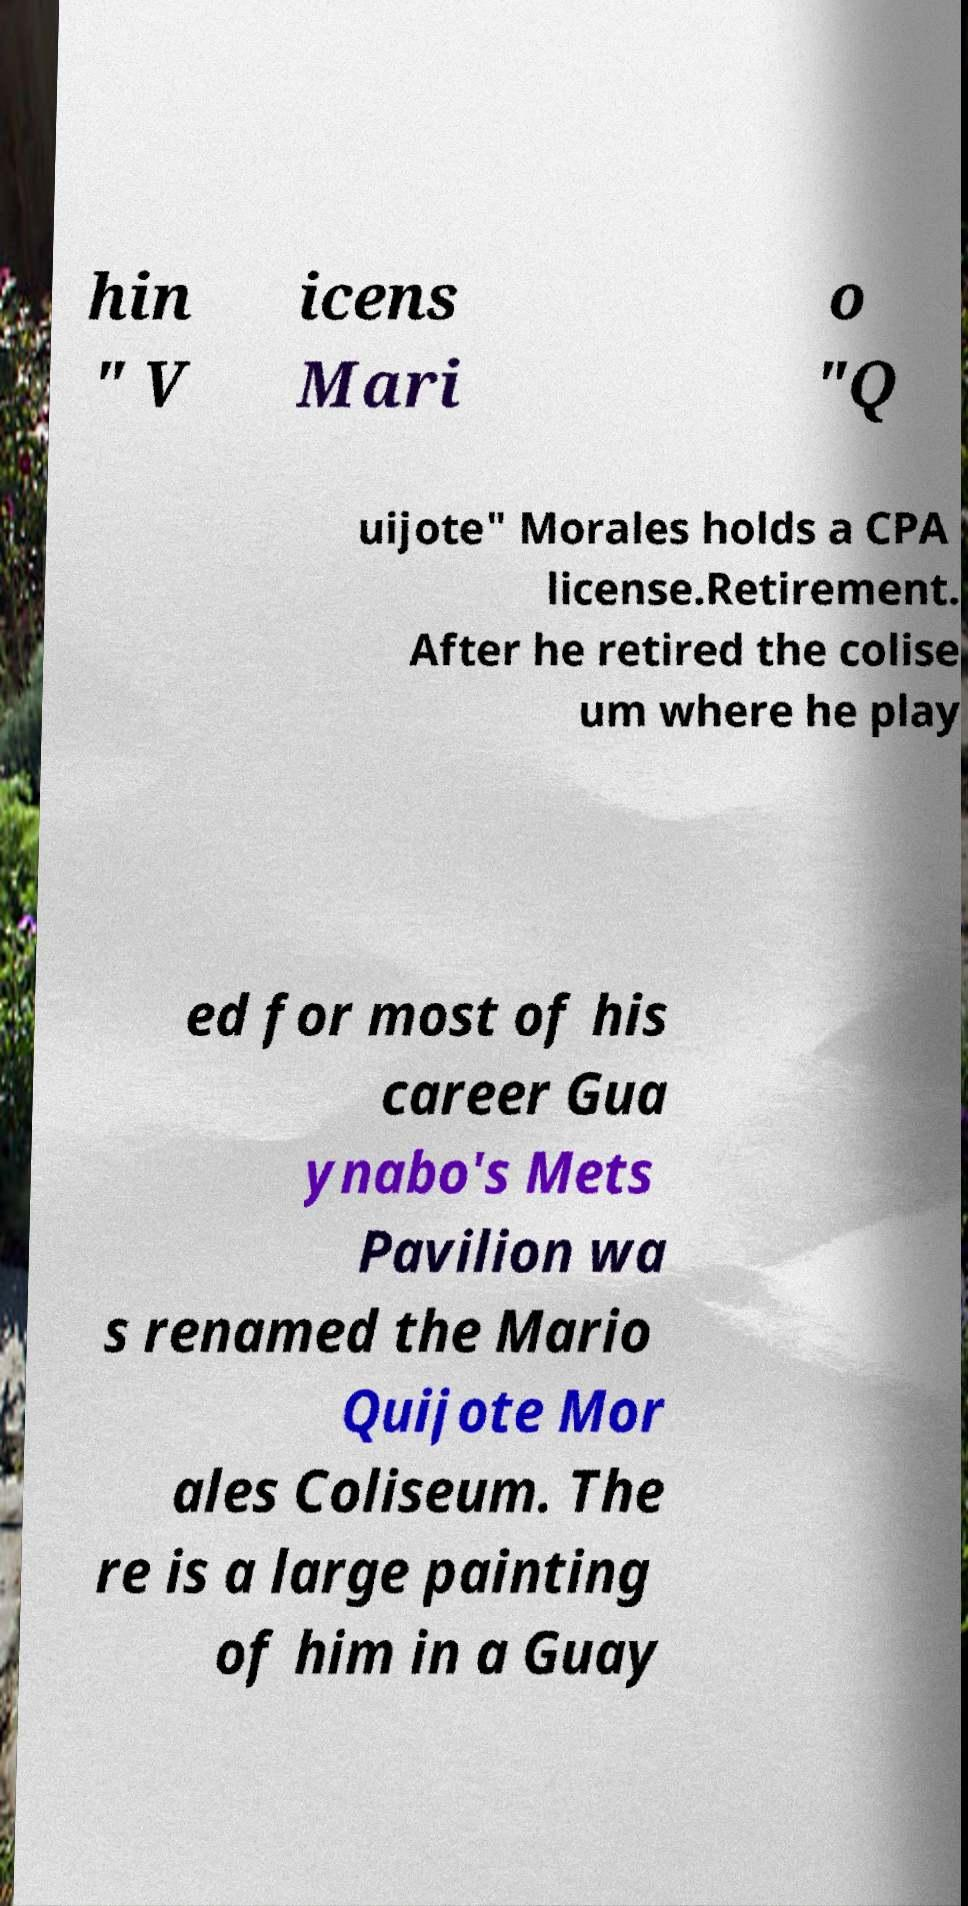Please identify and transcribe the text found in this image. hin " V icens Mari o "Q uijote" Morales holds a CPA license.Retirement. After he retired the colise um where he play ed for most of his career Gua ynabo's Mets Pavilion wa s renamed the Mario Quijote Mor ales Coliseum. The re is a large painting of him in a Guay 